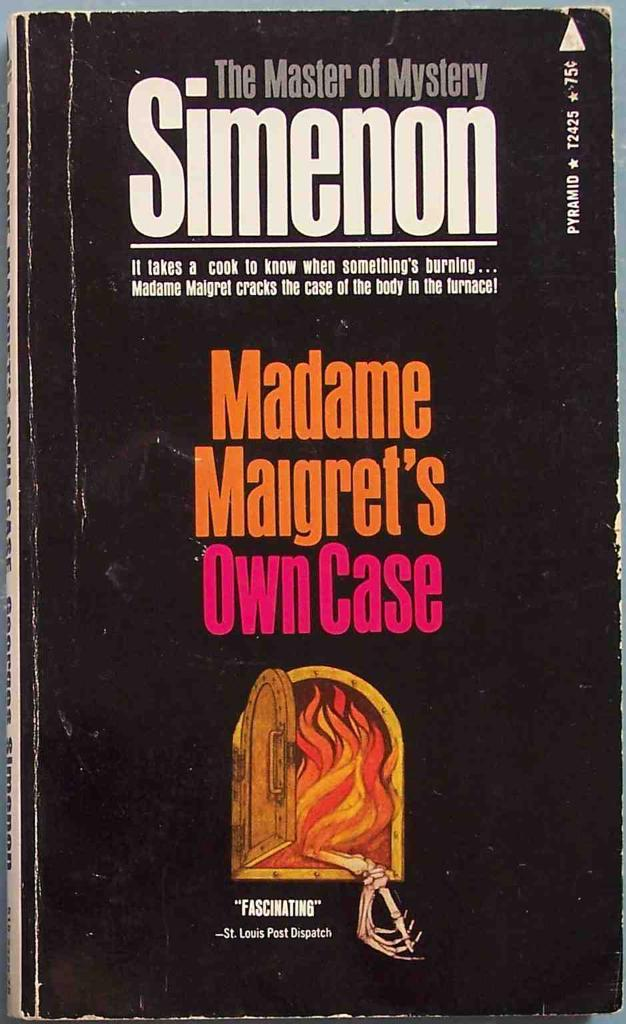<image>
Share a concise interpretation of the image provided. The book is called The Master of Mystery Simenon 